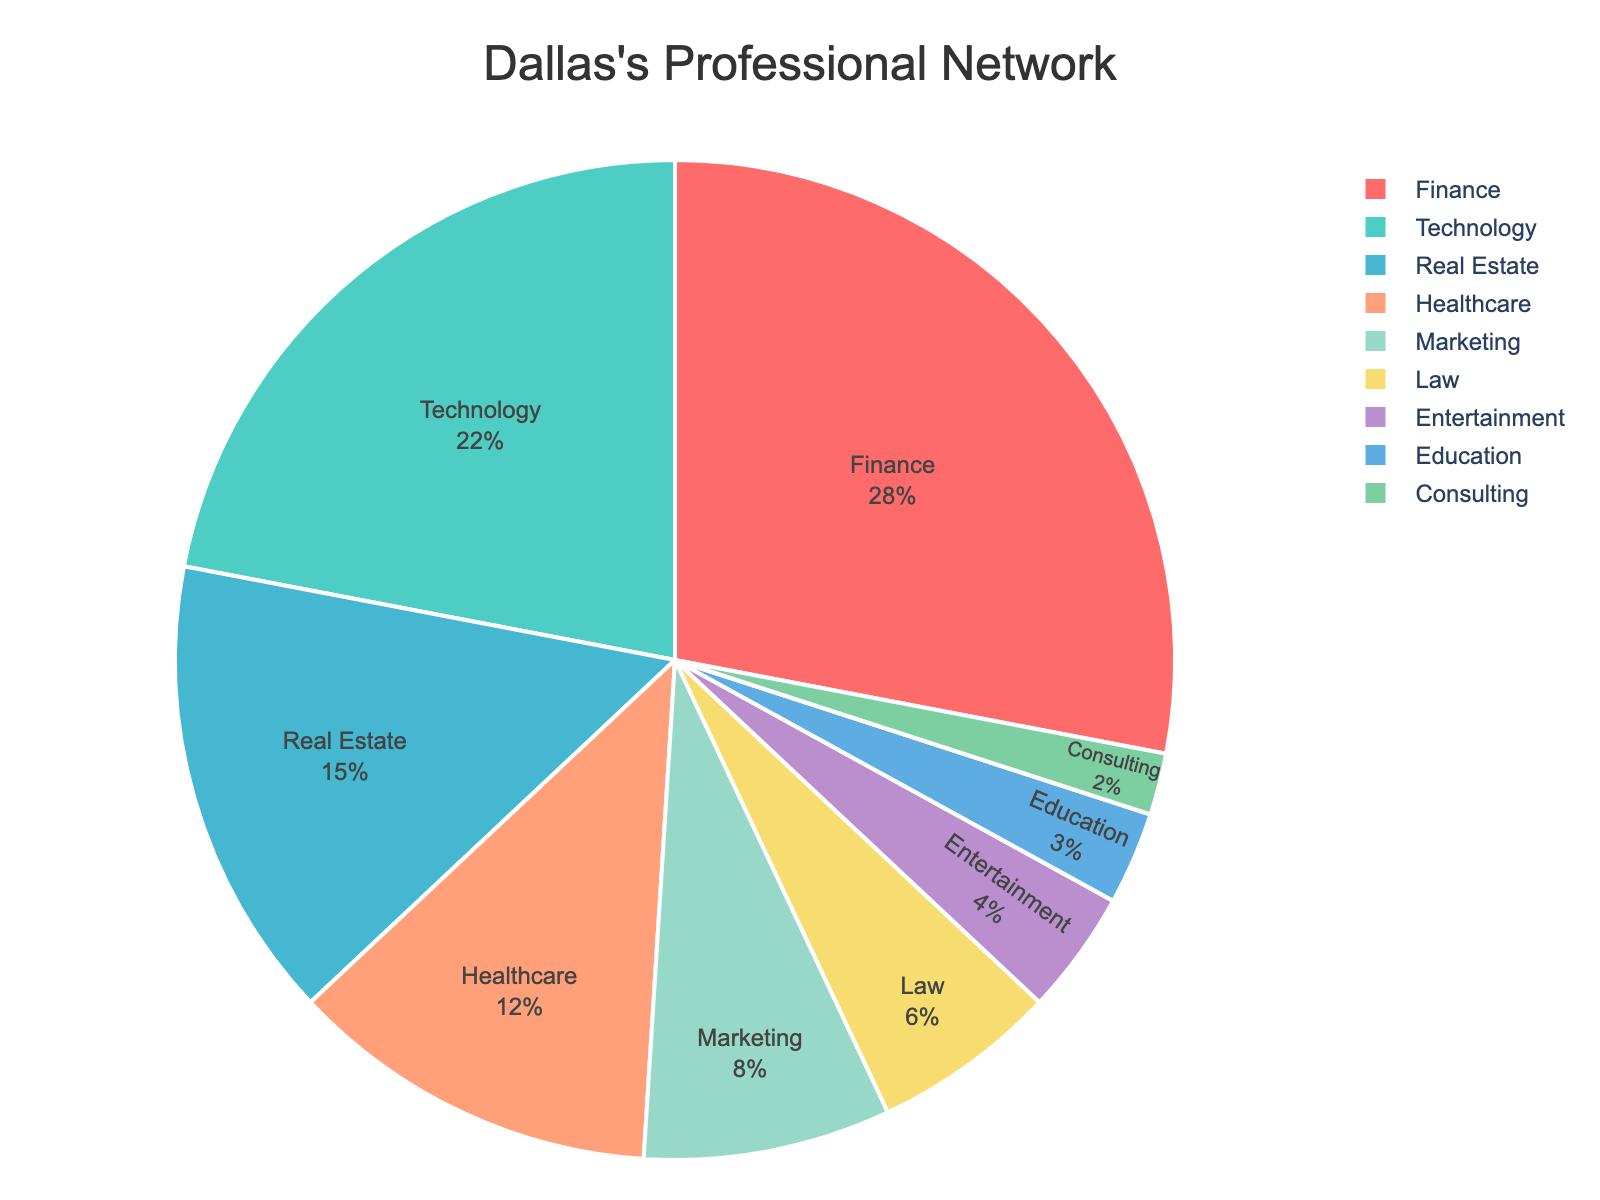Which industry occupies the largest portion of Dallas's professional network? The largest portion is represented by the biggest slice in the pie chart. The finance industry's slice appears to be the largest.
Answer: Finance Which two industries combined make up over 50% of Dallas's professional network? Adding the percentages from the figure, Finance (28%) and Technology (22%) combine for a total percentage of 28% + 22% = 50%.
Answer: Finance and Technology What is the total percentage of the network composed of the Real Estate, Healthcare, and Marketing industries? Adding the percentages shown in the chart for these three industries: Real Estate (15%) + Healthcare (12%) + Marketing (8%) = 35%.
Answer: 35% Which industry has the smallest representation in Dallas's professional network? This is identified by the smallest segment in the pie chart, which is Consulting at 2%.
Answer: Consulting What is the difference in network composition between the Marketing and Law industries? Subtract the percentage of the Law industry from the percentage of the Marketing industry: 8% - 6% = 2%.
Answer: 2% Is the proportion of Dallas's network in Technology greater than in Healthcare? Compare the percentages from the chart: Technology is 22%, and Healthcare is 12%. 22% is greater than 12%.
Answer: Yes Which industries combined equal the percentage representation of the Finance industry? Identifying combinations from the chart that sum to 28% (Finance): Real Estate (15%) + Healthcare (12%) + Education (3%) = 30% or Real Estate (15%) + Marketing (8%) + Education (3%) = 26%, neither combination is equal.
Answer: None In terms of network size, how does Healthcare compare to Real Estate? The Healthcare slice is 12%, and the Real Estate slice is 15%. Comparing these, Healthcare is less than Real Estate.
Answer: Less What is the aggregate percentage share of industries with less than 5% representation each? Summing the percentages for Law (6%), Entertainment (4%), Education (3%), and Consulting (2%): 6% + 4% + 3% + 2% = 15%.
Answer: 15% How do the combined shares of Education and Entertainment compare to the Technology industry? Adding Education (3%) and Entertainment (4%) gives 3% + 4% = 7%, which is significantly less than Technology's 22%.
Answer: Less 